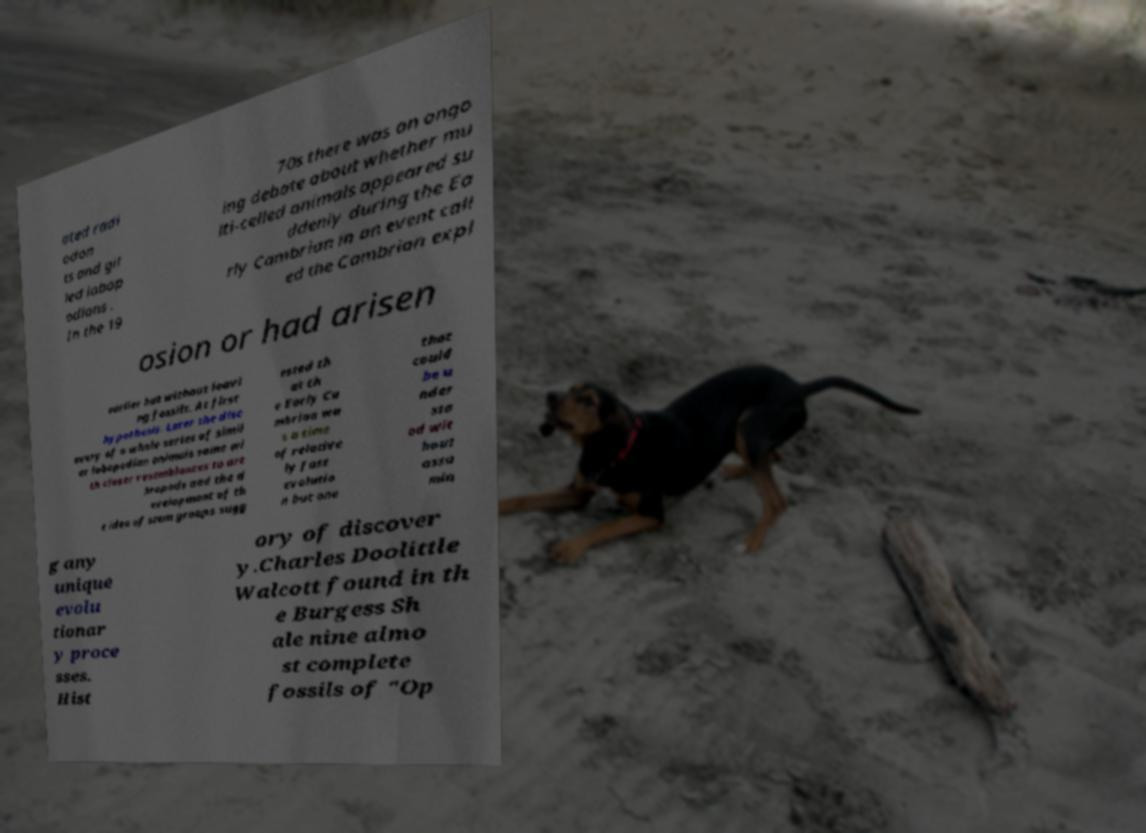Could you assist in decoding the text presented in this image and type it out clearly? ated radi odon ts and gil led lobop odians . In the 19 70s there was an ongo ing debate about whether mu lti-celled animals appeared su ddenly during the Ea rly Cambrian in an event call ed the Cambrian expl osion or had arisen earlier but without leavi ng fossils. At first hypothesis. Later the disc overy of a whole series of simil ar lobopodian animals some wi th closer resemblances to art hropods and the d evelopment of th e idea of stem groups sugg ested th at th e Early Ca mbrian wa s a time of relative ly fast evolutio n but one that could be u nder sto od wit hout assu min g any unique evolu tionar y proce sses. Hist ory of discover y.Charles Doolittle Walcott found in th e Burgess Sh ale nine almo st complete fossils of "Op 